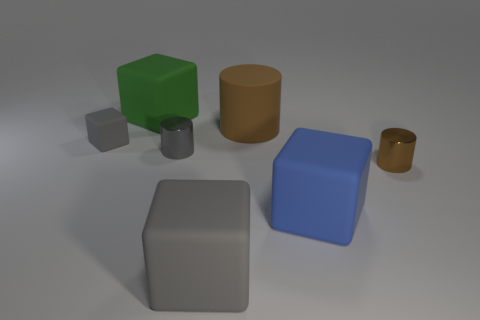Subtract 1 blocks. How many blocks are left? 3 Add 1 gray cylinders. How many objects exist? 8 Subtract all cylinders. How many objects are left? 4 Subtract 0 red cylinders. How many objects are left? 7 Subtract all green metal cylinders. Subtract all gray blocks. How many objects are left? 5 Add 5 small objects. How many small objects are left? 8 Add 1 green things. How many green things exist? 2 